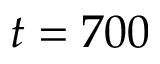Convert formula to latex. <formula><loc_0><loc_0><loc_500><loc_500>t = 7 0 0</formula> 